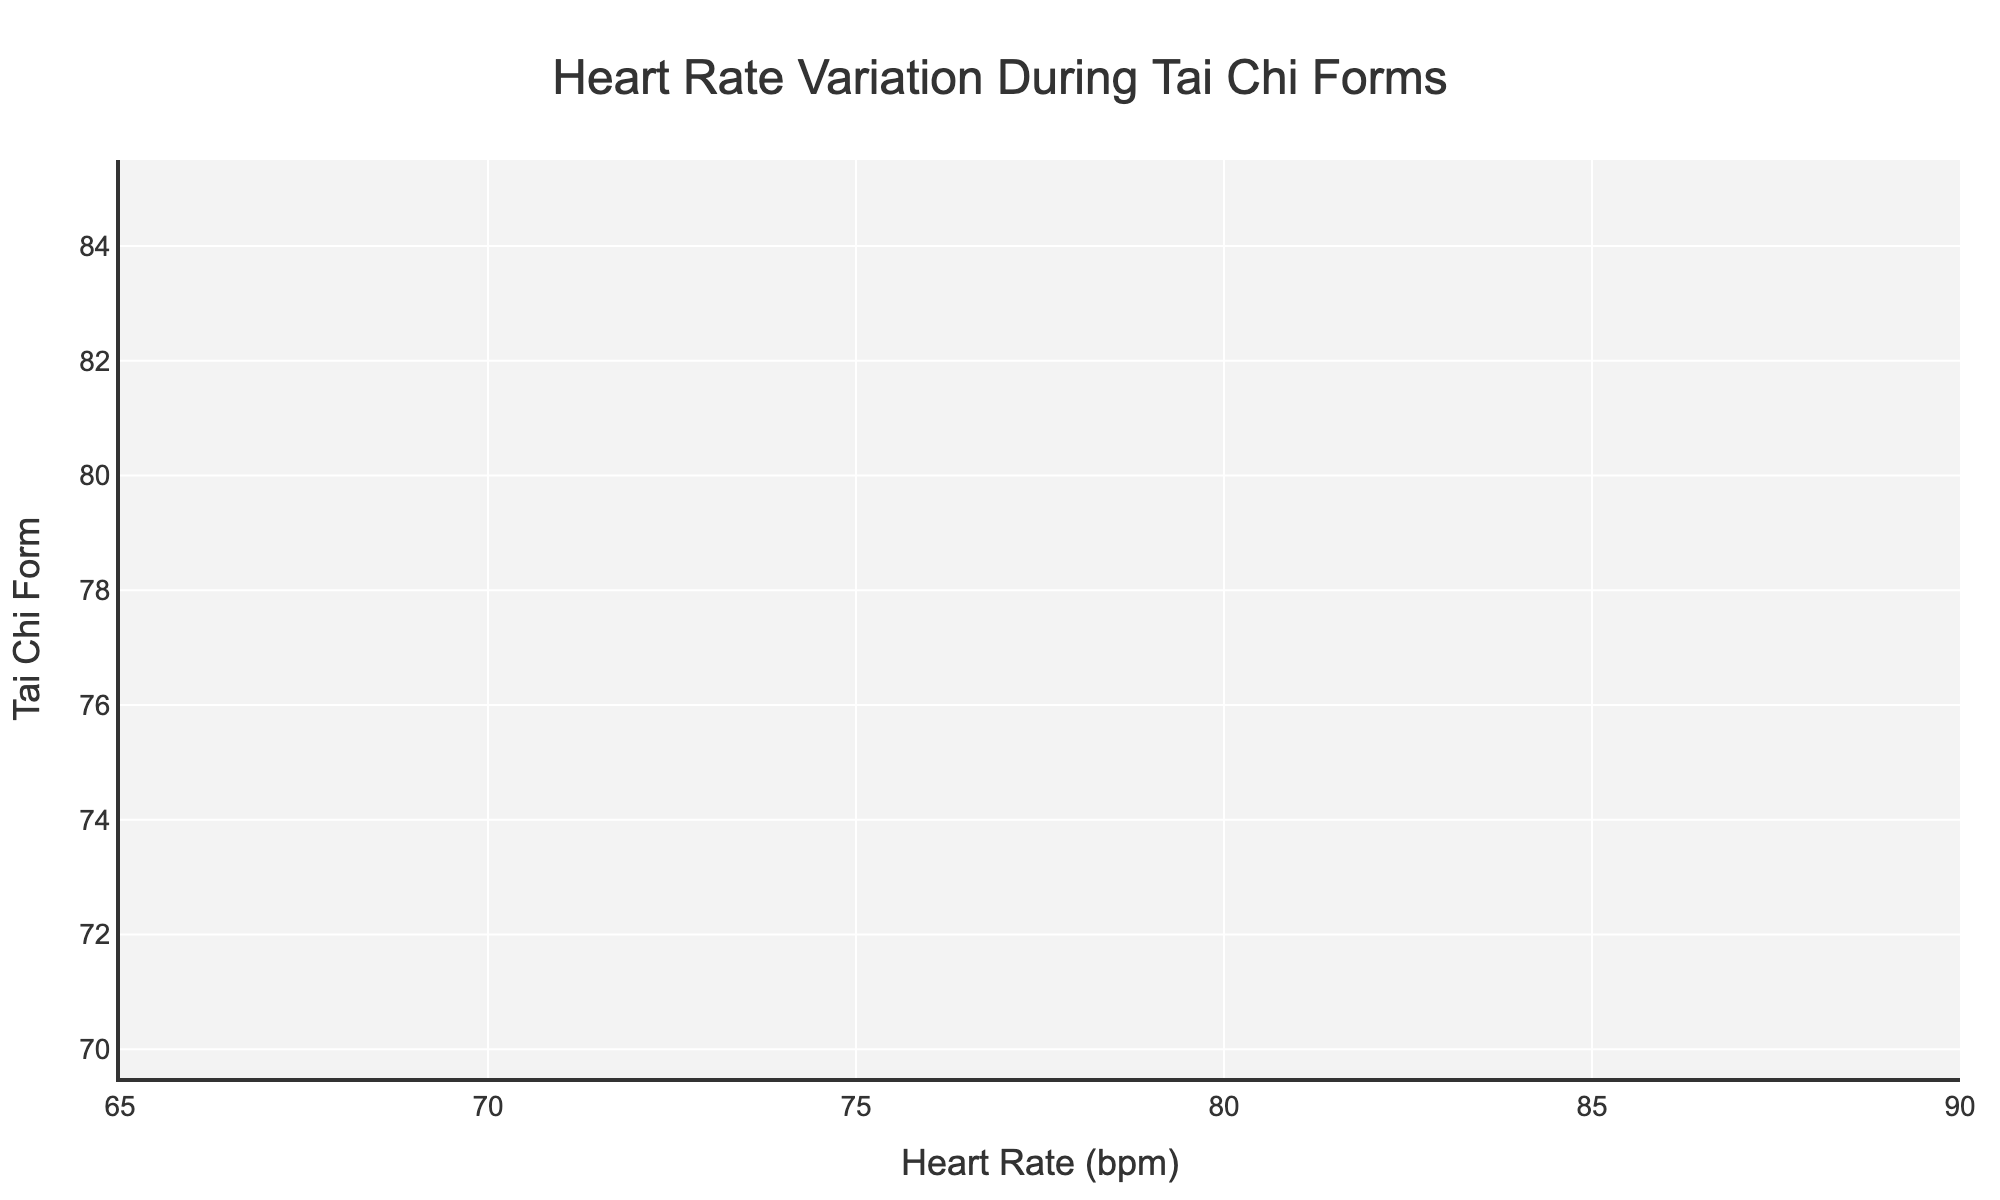What is the title of the plot? The title of the plot is located at the top and reads "Heart Rate Variation During Tai Chi Forms".
Answer: Heart Rate Variation During Tai Chi Forms Which Tai Chi form has the highest average heart rate? Look at the mean line within each violin plot. The highest mean line corresponds to the "Single Whip" form.
Answer: Single Whip What is the variation range of heart rates for "Grasp the Sparrow's Tail"? The variation range is from the minimum to maximum values of the "Grasp the Sparrow's Tail" violin plot. This ranges from 73 to 78 bpm.
Answer: 73 to 78 bpm How many data points are there for the "Wave Hands Like Clouds" form? Count the number of points within the "Wave Hands Like Clouds" violin plot. There are 5 visible data points.
Answer: 5 Which form shows the lowest minimum heart rate? Identify the lowest point along the x-axis for each violin plot. The "Wave Hands Like Clouds" form has the lowest minimum heart rate of 70 bpm.
Answer: Wave Hands Like Clouds Does "Part the Wild Horse’s Mane" have a larger range of heart rates compared to "Brush Knee and Twist Step"? Compare the ranges of both violin plots. "Part the Wild Horse’s Mane" has a range from 76 to 80 bpm, and "Brush Knee and Twist Step" has a range from 78 to 82 bpm. Therefore, both have the same range of 4 bpm.
Answer: No Which form’s violin plot appears the widest, indicating a greater spread in the data? Assess the width of each violin plot visually. "Single Whip" appears the widest, indicating a greater spread in heart rate data.
Answer: Single Whip In which form do we see the lowest maximum heart rate recorded? Identify the highest point along the x-axis for each violin plot. "Wave Hands Like Clouds" has the lowest maximum heart rate of 74 bpm.
Answer: Wave Hands Like Clouds Among the five forms shown, which one has a median heart rate closest to 80 bpm? Look at the mean line within each violin plot to find the ones closest to 80 bpm. Both "Single Whip" and "Brush Knee and Twist Step" have median heart rates closest to 80 bpm.
Answer: Single Whip, Brush Knee and Twist Step What is the x-axis title in the chart? The x-axis title is at the bottom along the axis and reads "Heart Rate (bpm)".
Answer: Heart Rate (bpm) 